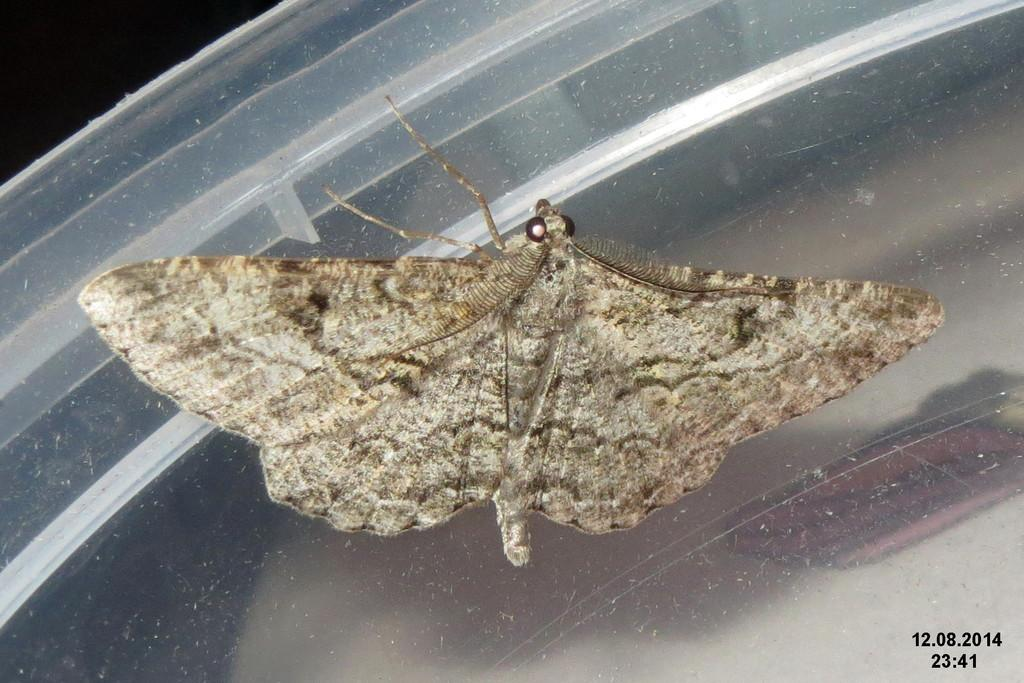What is the main subject of the image? There is a moth in the middle of the image. Where can the numbers be found in the image? The numbers are at the right bottom of the image. What is the color of the background in the image? The background of the image is dark. What type of swing can be seen in the image? There is no swing present in the image. What color is the ink used for the numbers in the image? There is no ink visible in the image, as the numbers are likely printed or digitally added. 